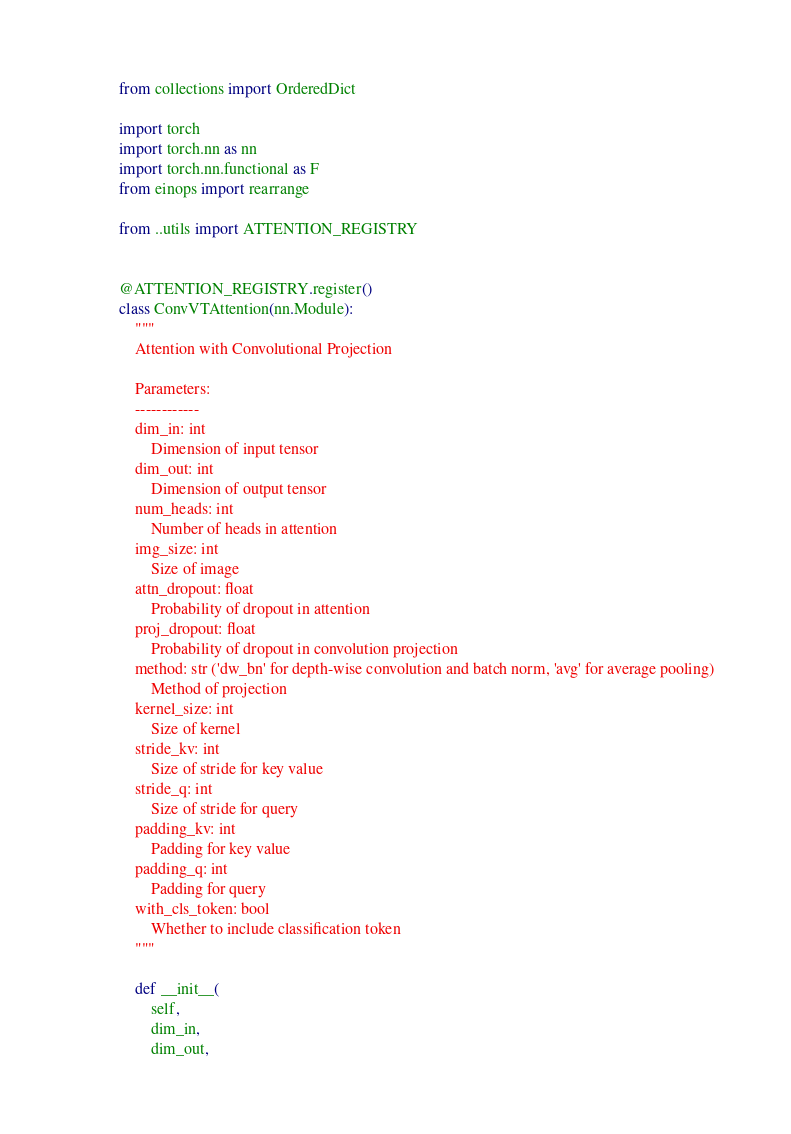<code> <loc_0><loc_0><loc_500><loc_500><_Python_>from collections import OrderedDict

import torch
import torch.nn as nn
import torch.nn.functional as F
from einops import rearrange

from ..utils import ATTENTION_REGISTRY


@ATTENTION_REGISTRY.register()
class ConvVTAttention(nn.Module):
    """
    Attention with Convolutional Projection

    Parameters:
    ------------
    dim_in: int
        Dimension of input tensor
    dim_out: int
        Dimension of output tensor
    num_heads: int
        Number of heads in attention
    img_size: int
        Size of image
    attn_dropout: float
        Probability of dropout in attention
    proj_dropout: float
        Probability of dropout in convolution projection
    method: str ('dw_bn' for depth-wise convolution and batch norm, 'avg' for average pooling)
        Method of projection
    kernel_size: int
        Size of kernel
    stride_kv: int
        Size of stride for key value
    stride_q: int
        Size of stride for query
    padding_kv: int
        Padding for key value
    padding_q: int
        Padding for query
    with_cls_token: bool
        Whether to include classification token
    """

    def __init__(
        self,
        dim_in,
        dim_out,</code> 